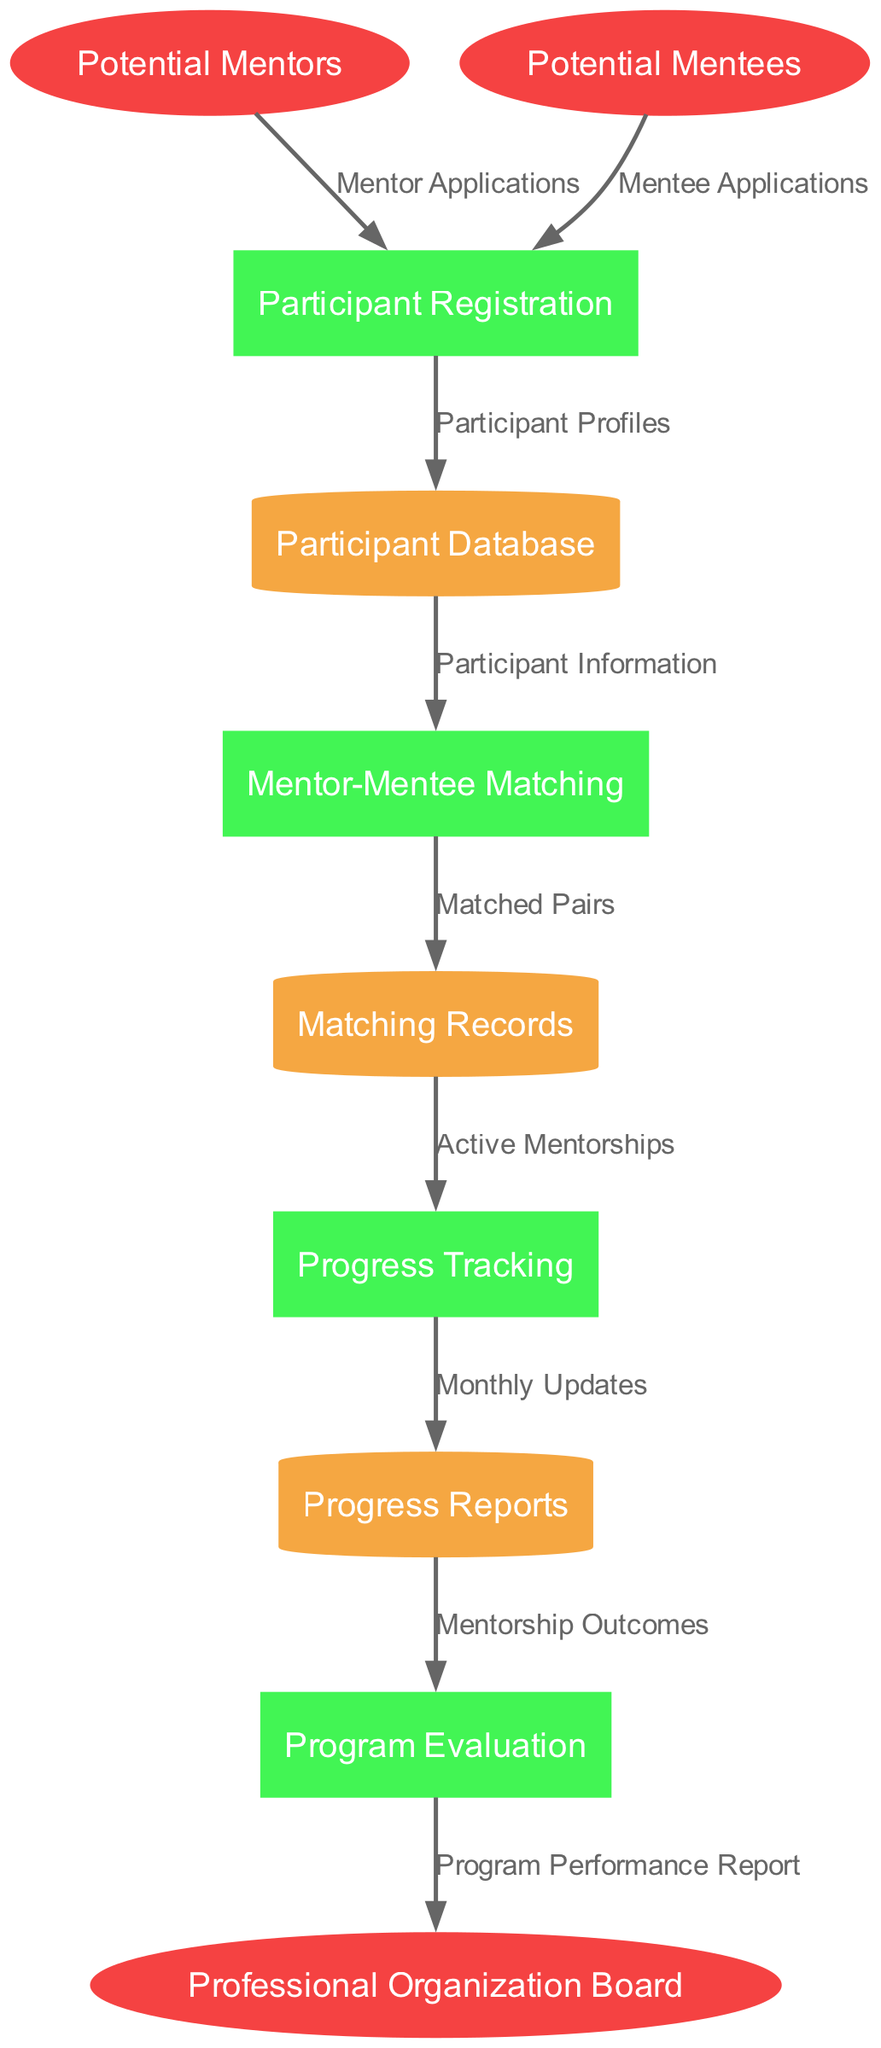What are the external entities in the diagram? The external entities listed in the diagram are Potential Mentors, Potential Mentees, and Professional Organization Board. These entities represent users or organizations that interact with the mentoring program.
Answer: Potential Mentors, Potential Mentees, Professional Organization Board How many processes are present in the diagram? By counting the processes listed, there are four distinct processes: Participant Registration, Mentor-Mentee Matching, Progress Tracking, and Program Evaluation. Therefore, the total number of processes is four.
Answer: 4 What data flow comes from Potential Mentees? The data flow that originates from Potential Mentees is labeled "Mentee Applications" and leads to the Participant Registration process. This indicates that Mentees apply to join the mentoring program via this flow.
Answer: Mentee Applications Which data store is used for tracking mentorship progress? The data store associated with tracking mentorship progress is called "Progress Reports." This store is where updates on the ongoing mentorships are recorded and can be accessed by the relevant processes.
Answer: Progress Reports What is the outcome of the Progress Tracking process? The outcome of the Progress Tracking process is the creation of "Monthly Updates," which is a data flow directed towards the Progress Reports data store. This indicates that the tracking generates regular updates for review.
Answer: Monthly Updates What is the final recipient of the Program Performance Report? The "Program Performance Report" is sent to the Professional Organization Board as the final output of the Program Evaluation process. This shows that the evaluation culminates in a report for the organization’s board.
Answer: Professional Organization Board How do Matching Records relate to Progress Tracking? The Matching Records serve as input into the Progress Tracking process via the flow labeled "Active Mentorships." This means that the information contained within Matching Records is necessary for tracking ongoing mentorships.
Answer: Active Mentorships What is the first step in the workflow? The first step in the workflow is Participant Registration, which receives data from both Potential Mentors and Potential Mentees through their respective application flows. This indicates the initiation of the program.
Answer: Participant Registration 